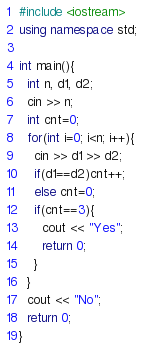Convert code to text. <code><loc_0><loc_0><loc_500><loc_500><_C++_>#include <iostream>
using namespace std;

int main(){
  int n, d1, d2;
  cin >> n;
  int cnt=0;
  for(int i=0; i<n; i++){
    cin >> d1 >> d2;
    if(d1==d2)cnt++;
    else cnt=0;
    if(cnt==3){
      cout << "Yes";
      return 0;
    }
  }
  cout << "No";
  return 0;
}</code> 